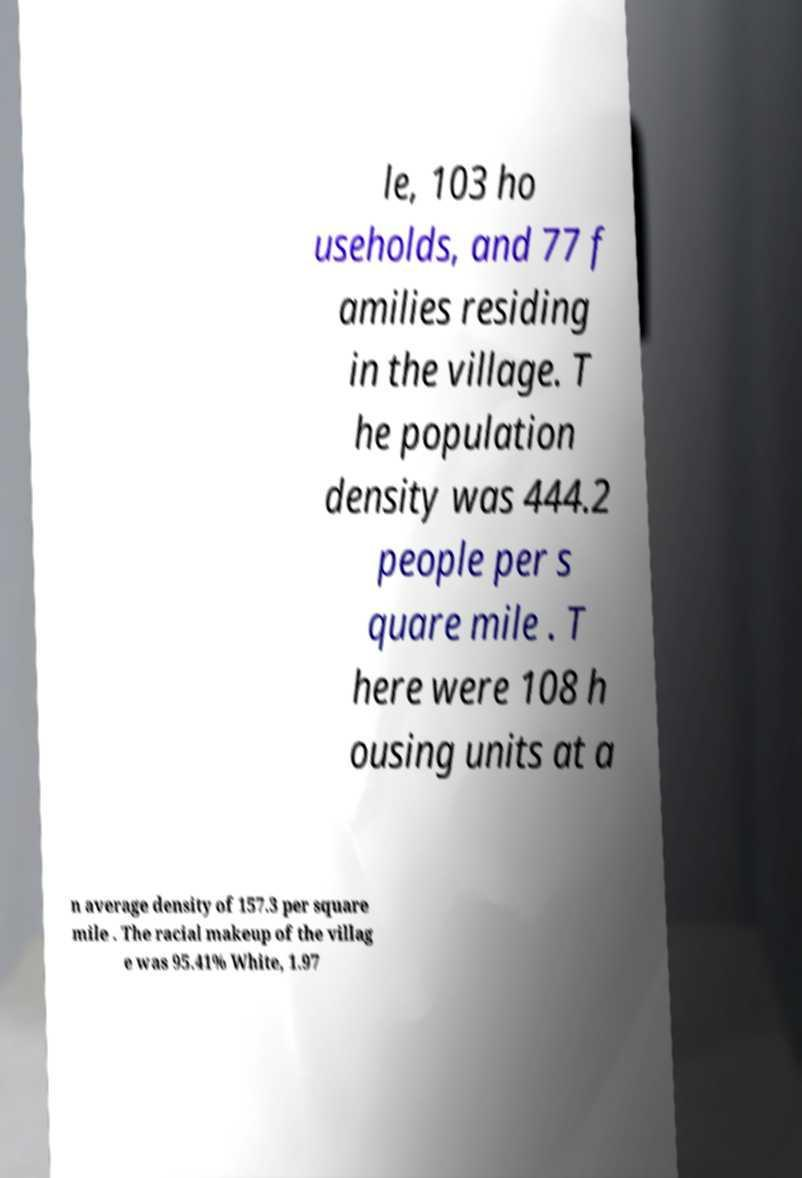Please read and relay the text visible in this image. What does it say? le, 103 ho useholds, and 77 f amilies residing in the village. T he population density was 444.2 people per s quare mile . T here were 108 h ousing units at a n average density of 157.3 per square mile . The racial makeup of the villag e was 95.41% White, 1.97 